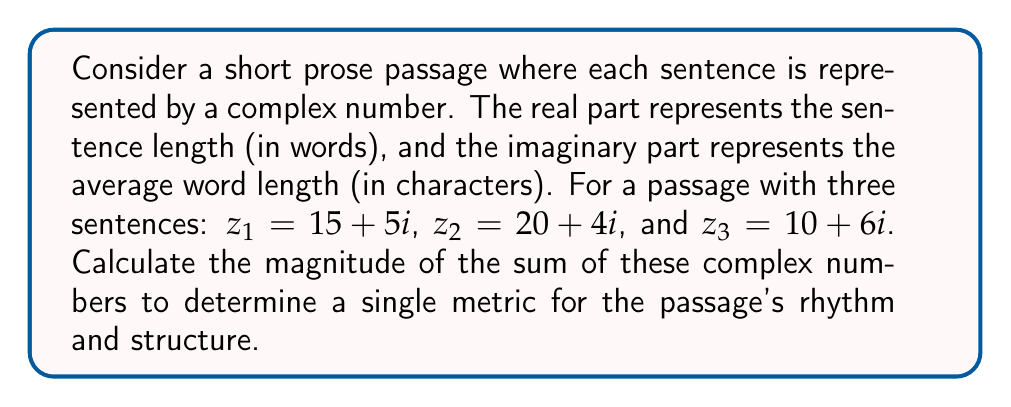Could you help me with this problem? To solve this problem, we'll follow these steps:

1) First, we need to sum the complex numbers:
   $z_{total} = z_1 + z_2 + z_3$
   $z_{total} = (15 + 5i) + (20 + 4i) + (10 + 6i)$
   $z_{total} = (15 + 20 + 10) + (5 + 4 + 6)i$
   $z_{total} = 45 + 15i$

2) Now, we need to calculate the magnitude of this sum. The magnitude of a complex number $a + bi$ is given by $\sqrt{a^2 + b^2}$.

3) In this case, we have:
   $|z_{total}| = \sqrt{45^2 + 15^2}$

4) Let's calculate:
   $|z_{total}| = \sqrt{2025 + 225}$
   $|z_{total}| = \sqrt{2250}$

5) Simplify:
   $|z_{total}| = 15\sqrt{10} \approx 47.43$

This final value represents a combined metric of the passage's rhythm and structure, taking into account both sentence length and average word length.
Answer: $15\sqrt{10}$ 